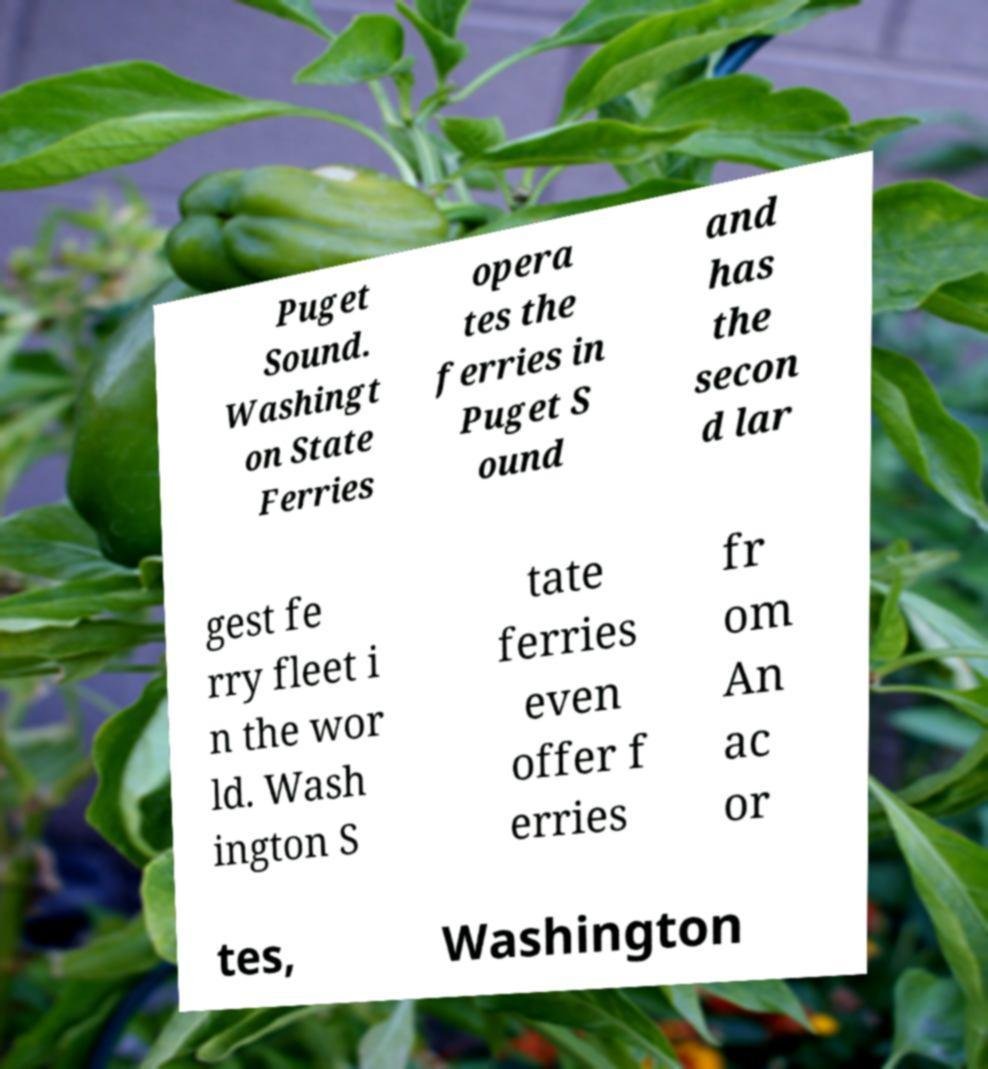Can you accurately transcribe the text from the provided image for me? Puget Sound. Washingt on State Ferries opera tes the ferries in Puget S ound and has the secon d lar gest fe rry fleet i n the wor ld. Wash ington S tate ferries even offer f erries fr om An ac or tes, Washington 